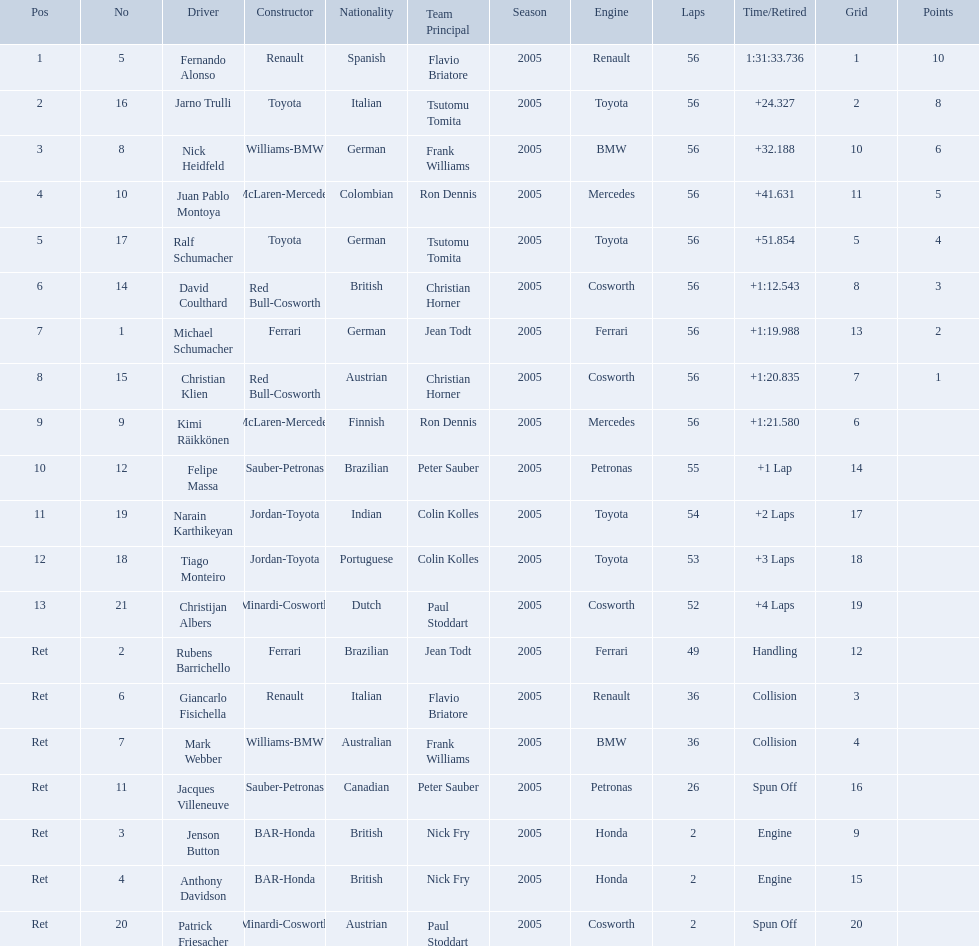Who raced during the 2005 malaysian grand prix? Fernando Alonso, Jarno Trulli, Nick Heidfeld, Juan Pablo Montoya, Ralf Schumacher, David Coulthard, Michael Schumacher, Christian Klien, Kimi Räikkönen, Felipe Massa, Narain Karthikeyan, Tiago Monteiro, Christijan Albers, Rubens Barrichello, Giancarlo Fisichella, Mark Webber, Jacques Villeneuve, Jenson Button, Anthony Davidson, Patrick Friesacher. What were their finishing times? 1:31:33.736, +24.327, +32.188, +41.631, +51.854, +1:12.543, +1:19.988, +1:20.835, +1:21.580, +1 Lap, +2 Laps, +3 Laps, +4 Laps, Handling, Collision, Collision, Spun Off, Engine, Engine, Spun Off. What was fernando alonso's finishing time? 1:31:33.736. 